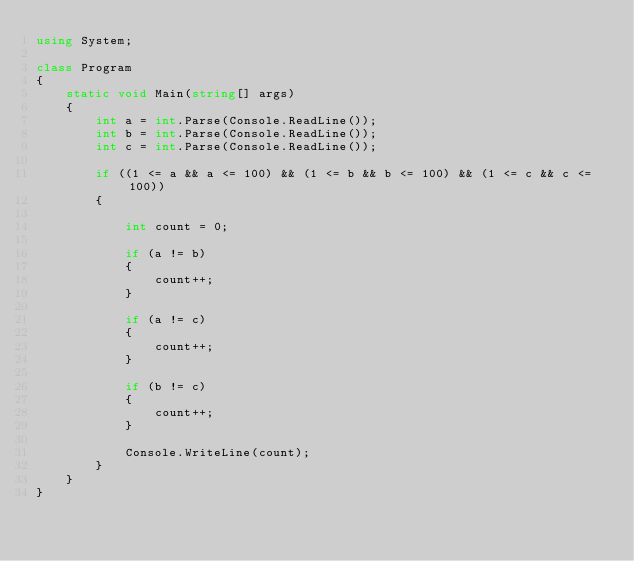<code> <loc_0><loc_0><loc_500><loc_500><_C#_>using System;

class Program
{
    static void Main(string[] args)
    {
        int a = int.Parse(Console.ReadLine());
        int b = int.Parse(Console.ReadLine());
        int c = int.Parse(Console.ReadLine());

        if ((1 <= a && a <= 100) && (1 <= b && b <= 100) && (1 <= c && c <= 100))
        {

            int count = 0;

            if (a != b)
            {
                count++;
            }

            if (a != c)
            {
                count++;
            }

            if (b != c)
            {
                count++;
            }

            Console.WriteLine(count);
        }
    }
}
</code> 